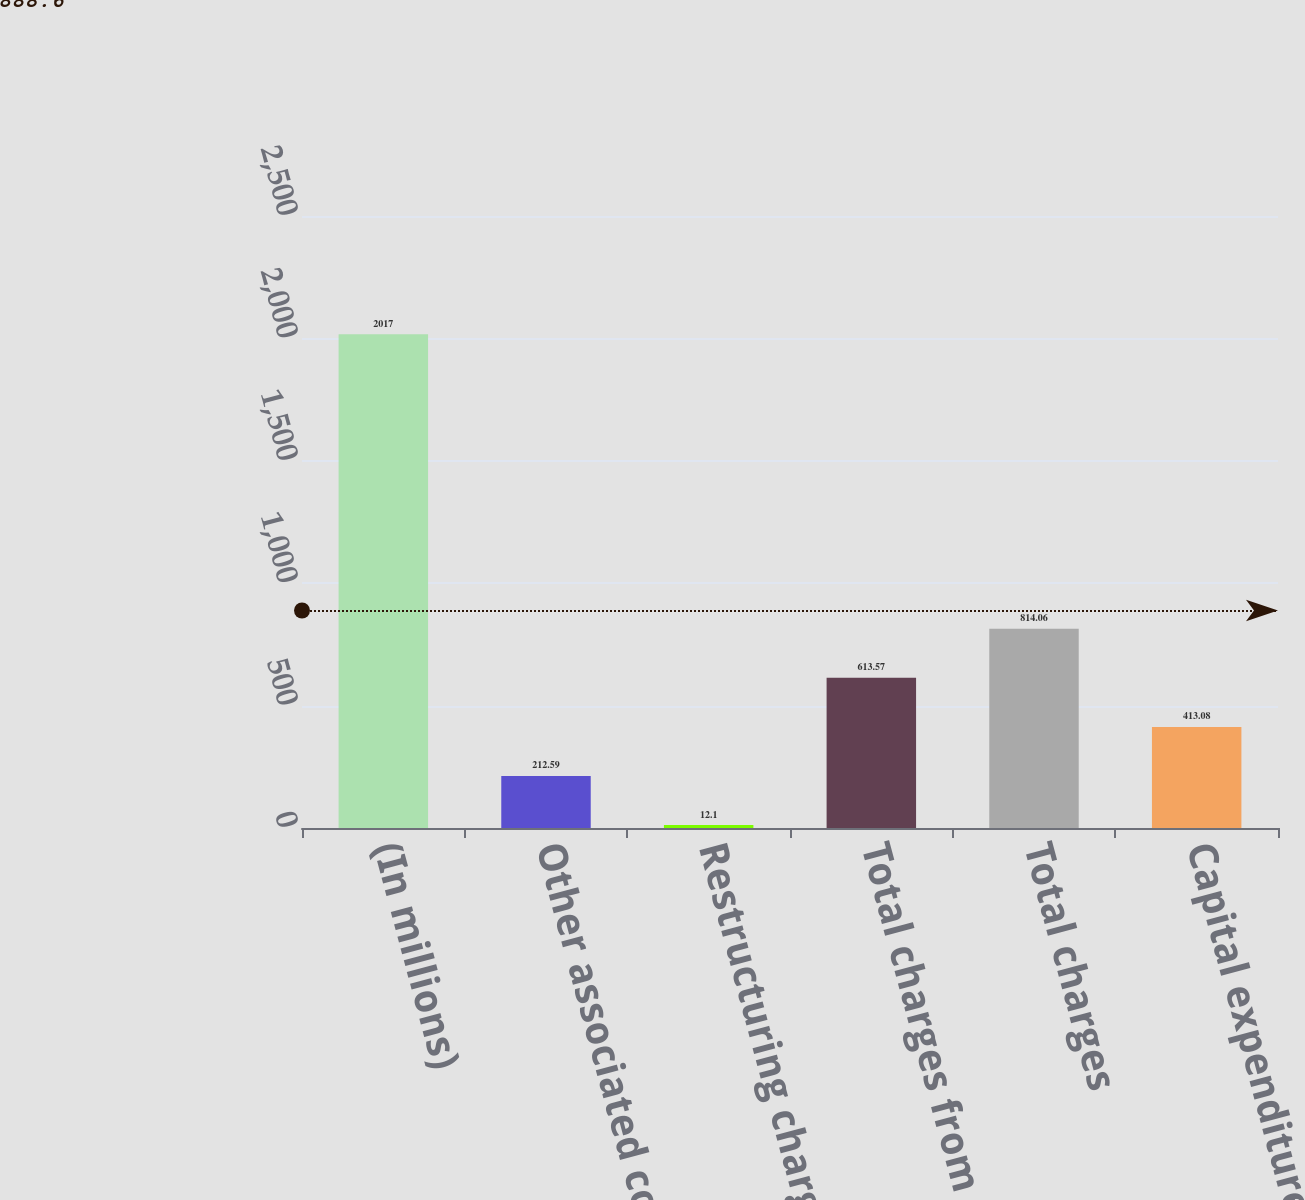Convert chart. <chart><loc_0><loc_0><loc_500><loc_500><bar_chart><fcel>(In millions)<fcel>Other associated costs (1)<fcel>Restructuring charges<fcel>Total charges from continuing<fcel>Total charges<fcel>Capital expenditures<nl><fcel>2017<fcel>212.59<fcel>12.1<fcel>613.57<fcel>814.06<fcel>413.08<nl></chart> 